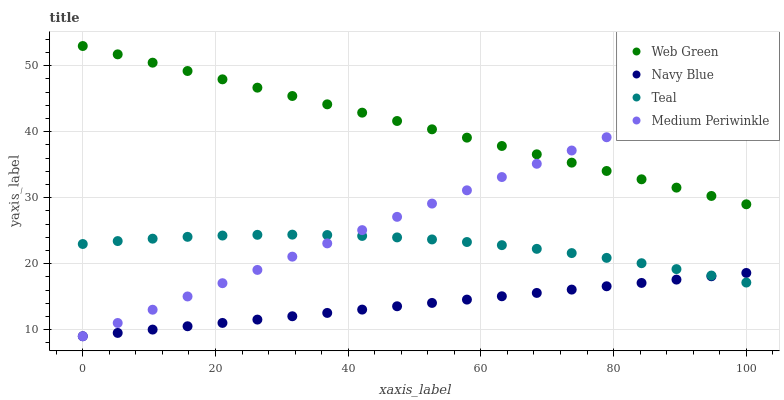Does Navy Blue have the minimum area under the curve?
Answer yes or no. Yes. Does Web Green have the maximum area under the curve?
Answer yes or no. Yes. Does Medium Periwinkle have the minimum area under the curve?
Answer yes or no. No. Does Medium Periwinkle have the maximum area under the curve?
Answer yes or no. No. Is Navy Blue the smoothest?
Answer yes or no. Yes. Is Teal the roughest?
Answer yes or no. Yes. Is Medium Periwinkle the smoothest?
Answer yes or no. No. Is Medium Periwinkle the roughest?
Answer yes or no. No. Does Navy Blue have the lowest value?
Answer yes or no. Yes. Does Teal have the lowest value?
Answer yes or no. No. Does Web Green have the highest value?
Answer yes or no. Yes. Does Medium Periwinkle have the highest value?
Answer yes or no. No. Is Navy Blue less than Web Green?
Answer yes or no. Yes. Is Web Green greater than Navy Blue?
Answer yes or no. Yes. Does Web Green intersect Medium Periwinkle?
Answer yes or no. Yes. Is Web Green less than Medium Periwinkle?
Answer yes or no. No. Is Web Green greater than Medium Periwinkle?
Answer yes or no. No. Does Navy Blue intersect Web Green?
Answer yes or no. No. 